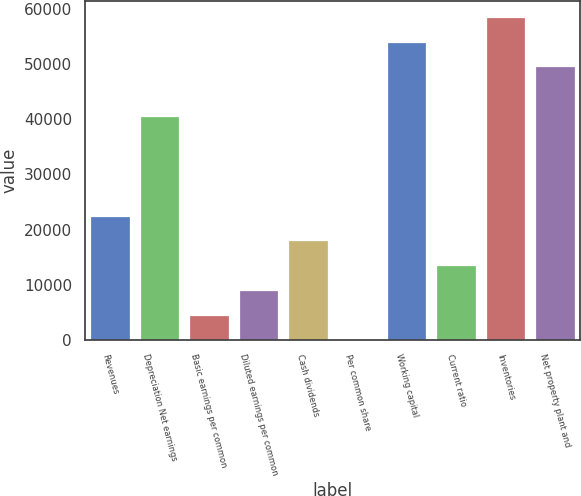<chart> <loc_0><loc_0><loc_500><loc_500><bar_chart><fcel>Revenues<fcel>Depreciation Net earnings<fcel>Basic earnings per common<fcel>Diluted earnings per common<fcel>Cash dividends<fcel>Per common share<fcel>Working capital<fcel>Current ratio<fcel>Inventories<fcel>Net property plant and<nl><fcel>22550.2<fcel>40590<fcel>4510.32<fcel>9020.28<fcel>18040.2<fcel>0.35<fcel>54119.9<fcel>13530.2<fcel>58629.9<fcel>49610<nl></chart> 